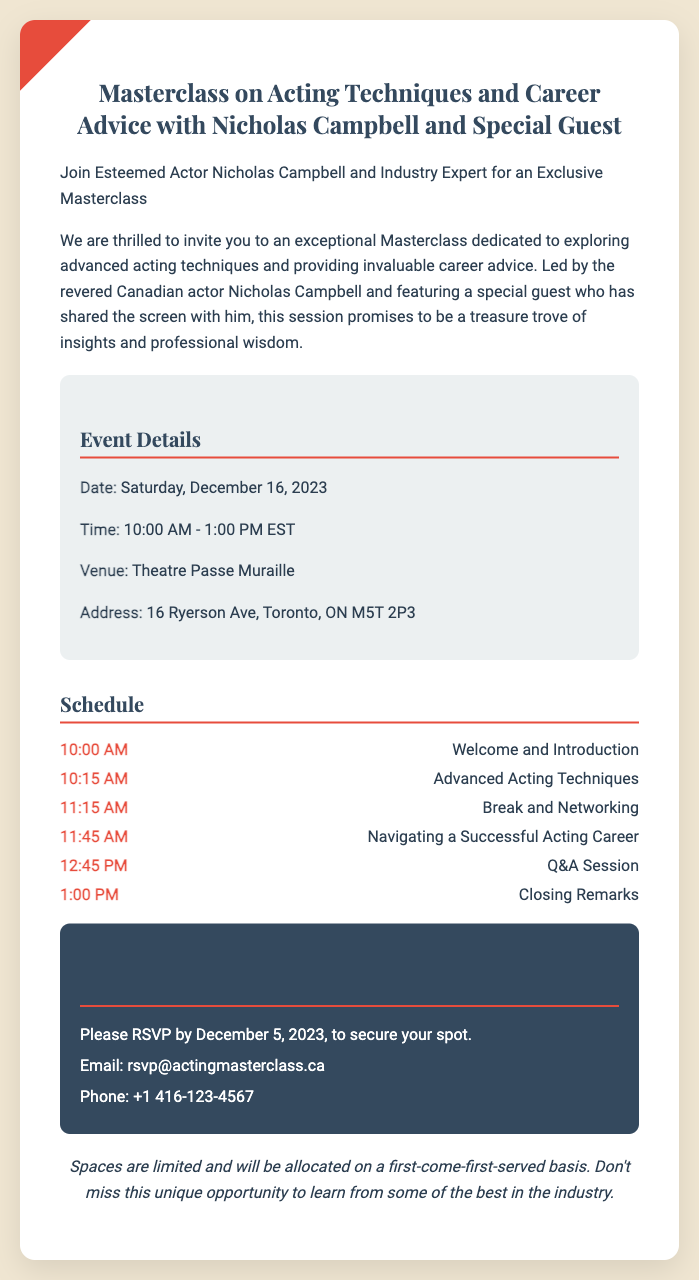What is the date of the event? The date of the event is explicitly stated in the document as Saturday, December 16, 2023.
Answer: Saturday, December 16, 2023 What time does the Masterclass start? The start time is mentioned in the event details, which indicates the Masterclass begins at 10:00 AM.
Answer: 10:00 AM Who is the main presenter of the Masterclass? The document highlights Nicholas Campbell as the esteemed actor leading the Masterclass.
Answer: Nicholas Campbell What venue will the event be held at? The venue for the event is provided in the document and is Theatre Passe Muraille.
Answer: Theatre Passe Muraille When is the RSVP deadline? The RSVP deadline is clearly indicated in the RSVP details section as December 5, 2023.
Answer: December 5, 2023 What is the duration of the entire Masterclass? By analyzing the start and end times mentioned, the Masterclass lasts from 10:00 AM to 1:00 PM, which totals 3 hours.
Answer: 3 hours How can attendees confirm their attendance? The document specifies that attendees can RSVP via email or phone, providing contact details for both.
Answer: Email or phone What is emphasized regarding seating for the event? The document states that spaces are limited and allocated on a first-come-first-served basis, which emphasizes the importance of early RSVP.
Answer: First-come-first-served basis 